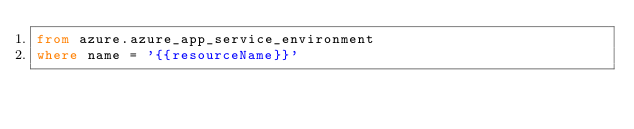Convert code to text. <code><loc_0><loc_0><loc_500><loc_500><_SQL_>from azure.azure_app_service_environment
where name = '{{resourceName}}'
</code> 